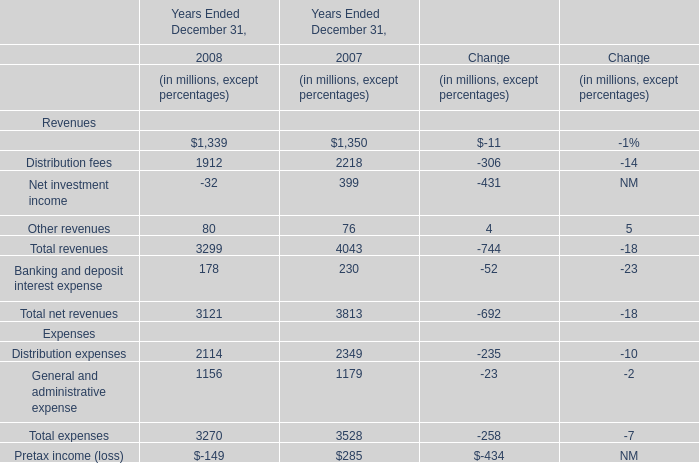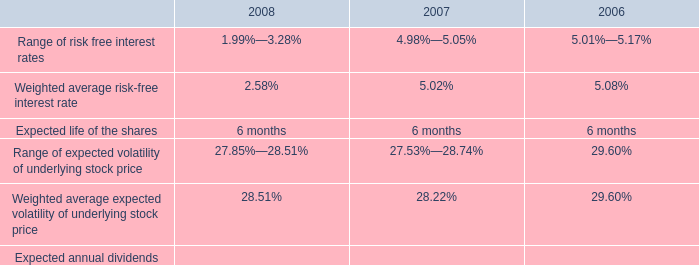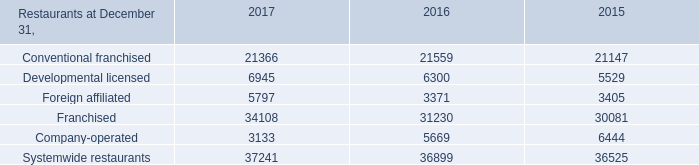what is the growth rate in the price of espp shares purchased from 2006 to 2007? 
Computations: ((9.09 - 6.79) / 6.79)
Answer: 0.33873. 